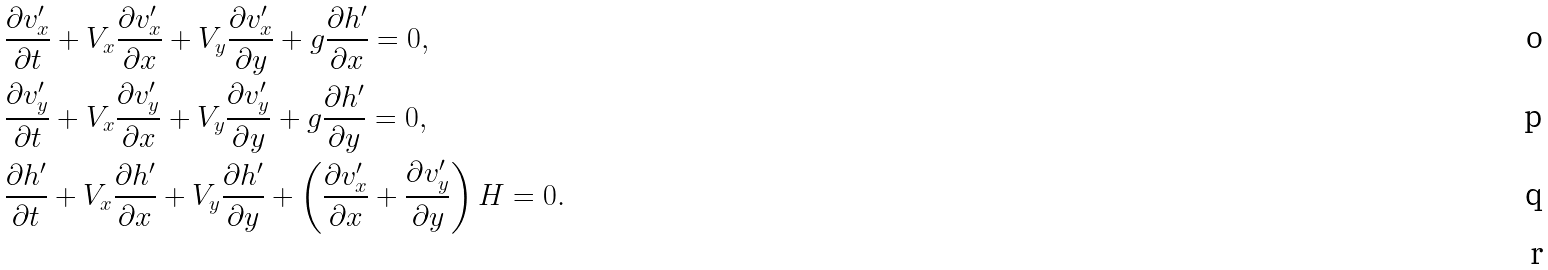Convert formula to latex. <formula><loc_0><loc_0><loc_500><loc_500>& \frac { \partial v ^ { \prime } _ { x } } { \partial t } + V _ { x } \frac { \partial v ^ { \prime } _ { x } } { \partial x } + V _ { y } \frac { \partial v ^ { \prime } _ { x } } { \partial y } + g \frac { \partial h ^ { \prime } } { \partial x } = 0 , \\ & \frac { \partial v ^ { \prime } _ { y } } { \partial t } + V _ { x } \frac { \partial v ^ { \prime } _ { y } } { \partial x } + V _ { y } \frac { \partial v ^ { \prime } _ { y } } { \partial y } + g \frac { \partial h ^ { \prime } } { \partial y } = 0 , \\ & \frac { \partial h ^ { \prime } } { \partial t } + V _ { x } \frac { \partial h ^ { \prime } } { \partial x } + V _ { y } \frac { \partial h ^ { \prime } } { \partial y } + \left ( \frac { \partial v ^ { \prime } _ { x } } { \partial x } + \frac { \partial v ^ { \prime } _ { y } } { \partial y } \right ) H = 0 . \\</formula> 